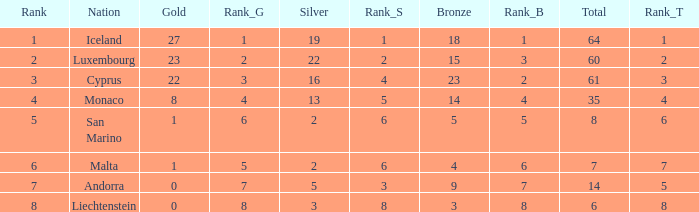Where does Iceland rank with under 19 silvers? None. 